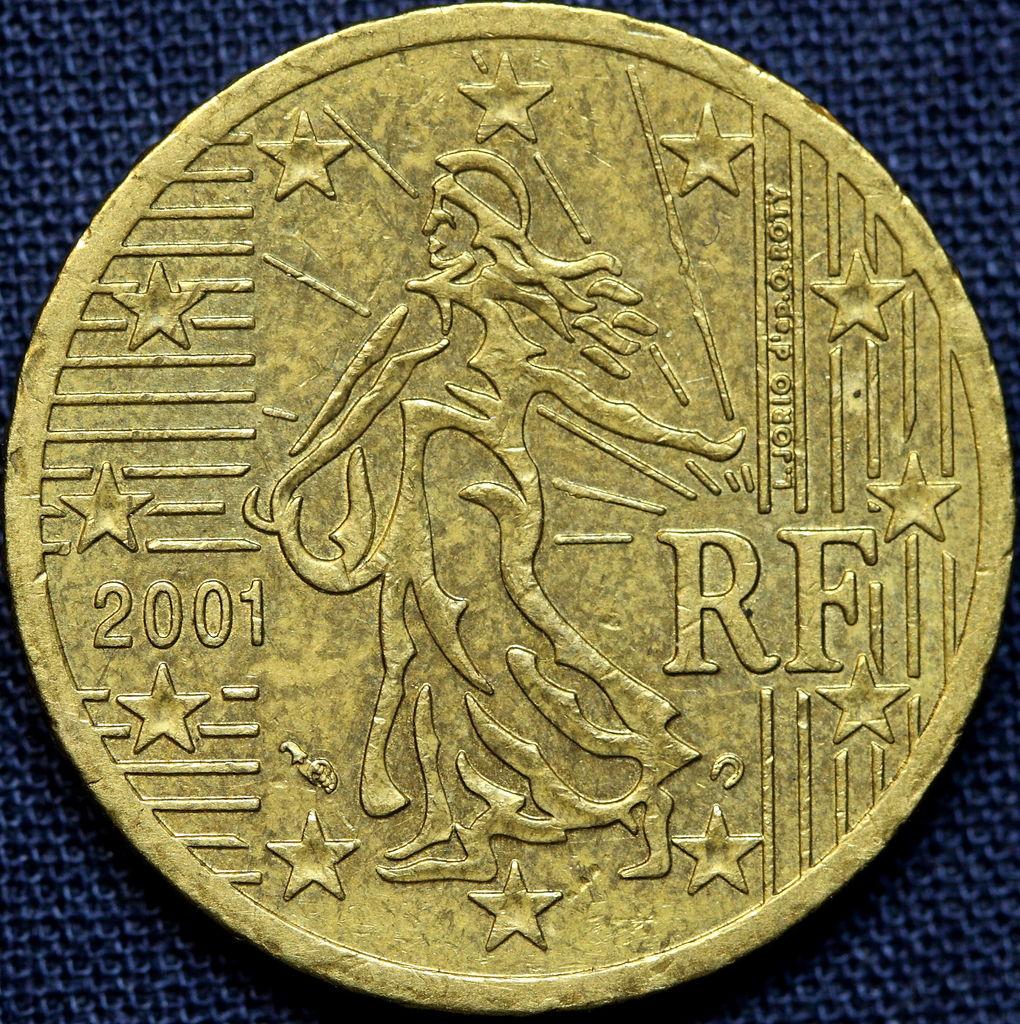What year is imprinted on this coin?
Ensure brevity in your answer.  2001. 